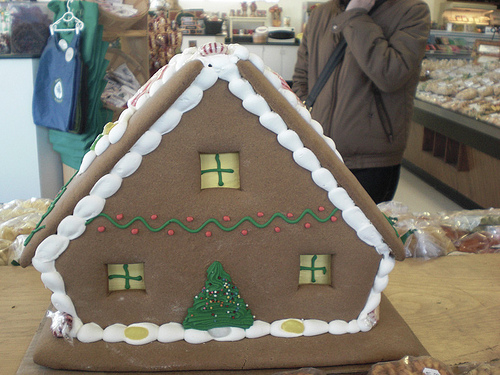<image>
Is the person in front of the gingerbread house? No. The person is not in front of the gingerbread house. The spatial positioning shows a different relationship between these objects. 